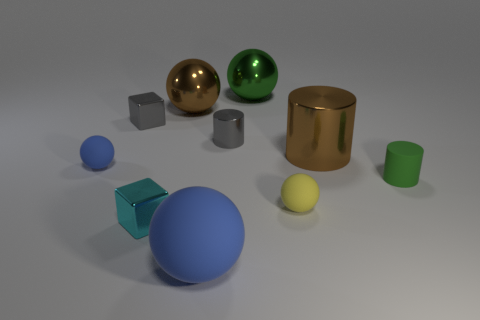Is there a tiny rubber sphere of the same color as the rubber cylinder?
Keep it short and to the point. No. What is the shape of the tiny thing that is both on the right side of the cyan metal thing and behind the tiny blue rubber ball?
Offer a very short reply. Cylinder. What number of green cylinders have the same material as the tiny blue sphere?
Ensure brevity in your answer.  1. Is the number of things on the right side of the brown shiny cylinder less than the number of gray shiny objects in front of the green shiny thing?
Provide a succinct answer. Yes. The block in front of the tiny matte sphere that is right of the large brown metal thing that is left of the large rubber thing is made of what material?
Your response must be concise. Metal. How big is the matte thing that is on the right side of the large blue rubber sphere and on the left side of the big shiny cylinder?
Your answer should be compact. Small. How many spheres are either metallic objects or small yellow rubber things?
Offer a terse response. 3. What color is the shiny cylinder that is the same size as the green matte cylinder?
Make the answer very short. Gray. Are there any other things that are the same shape as the cyan thing?
Offer a terse response. Yes. What is the color of the other thing that is the same shape as the cyan object?
Your answer should be compact. Gray. 